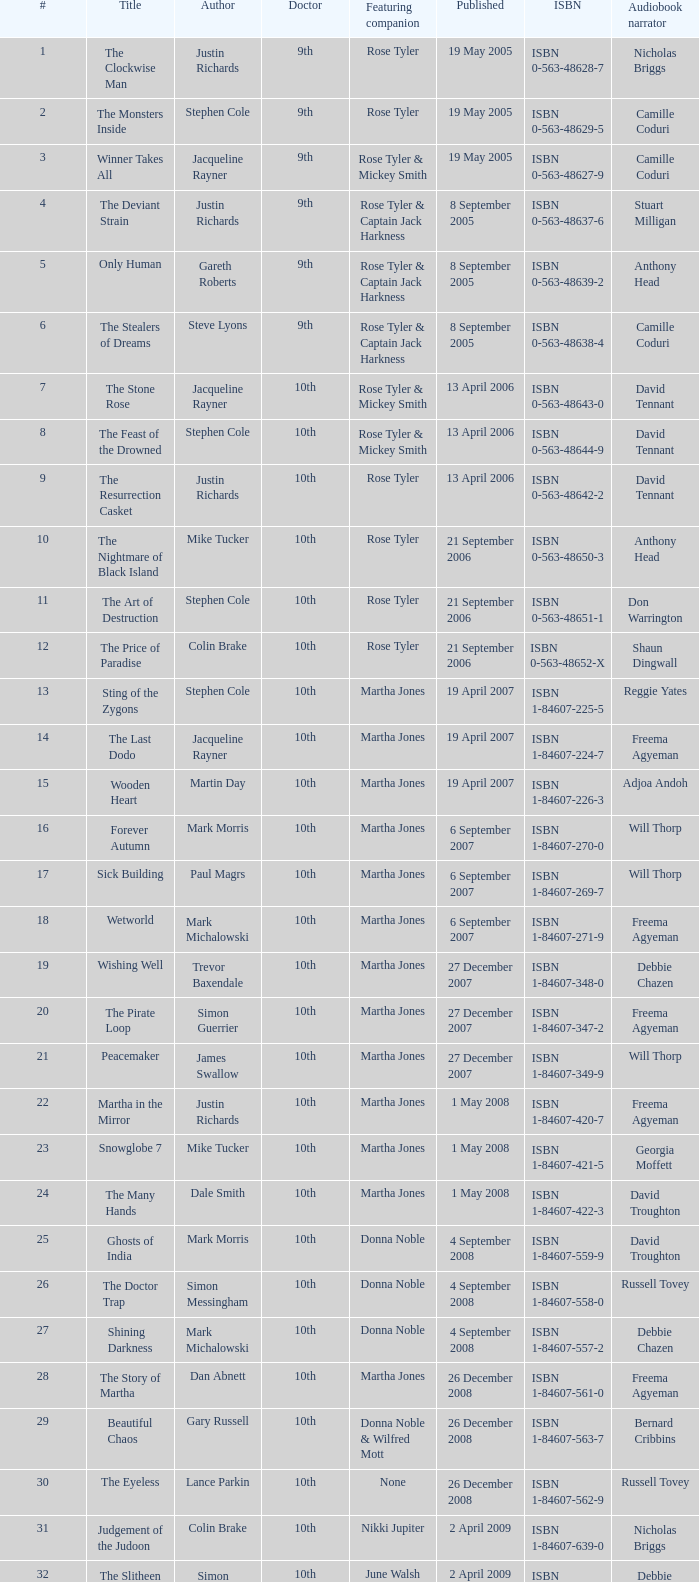On what date was the book with narration by michael maloney published? 29 September 2011. 